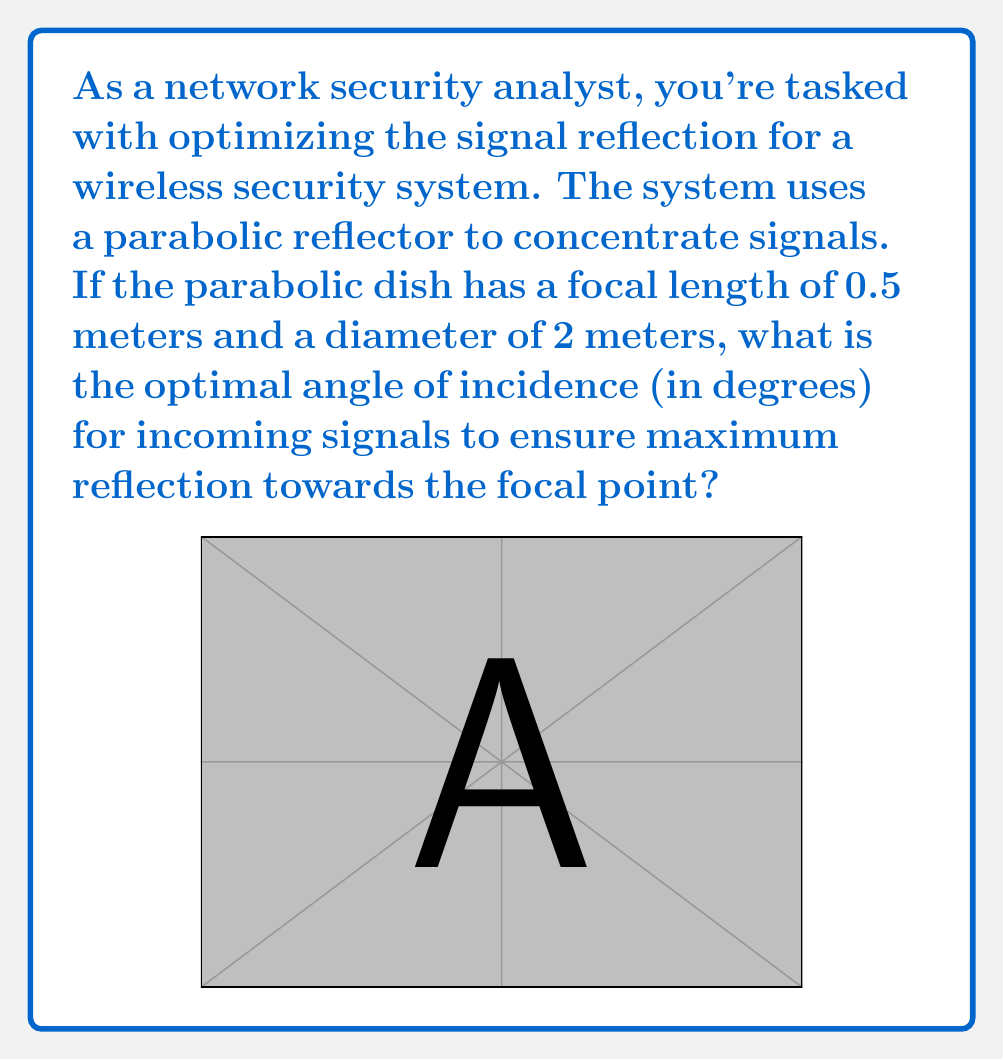Help me with this question. To solve this problem, we need to understand the geometry of a parabolic reflector and use the properties of parabolas.

1) In a parabolic reflector, the optimal angle of incidence is the angle between the incoming signal and the axis of symmetry of the parabola. This angle ensures that all signals are reflected towards the focal point.

2) For a parabola with focal length $f$ and diameter $d$, we can use the equation:

   $$y = \frac{x^2}{4f}$$

3) The angle we're looking for is the angle between the axis of symmetry and the line from the edge of the dish to the focal point.

4) At the edge of the dish, $x = d/2$ and $y = h$ (the depth of the dish). We can find $h$ using the parabola equation:

   $$h = \frac{(d/2)^2}{4f} = \frac{d^2}{16f}$$

5) Now we have a right triangle with:
   - Base = $d/2$
   - Height = $f$
   - Hypotenuse = line from edge to focal point

6) The angle we want is the angle between the hypotenuse and the vertical line. We can find this using the arctangent function:

   $$\theta = \arctan(\frac{d/2}{f}) = \arctan(\frac{d}{2f})$$

7) Plugging in our values:

   $$\theta = \arctan(\frac{2}{2(0.5)}) = \arctan(2)$$

8) Converting to degrees:

   $$\theta = \arctan(2) \cdot \frac{180}{\pi}$$
Answer: $\theta \approx 63.43°$ 